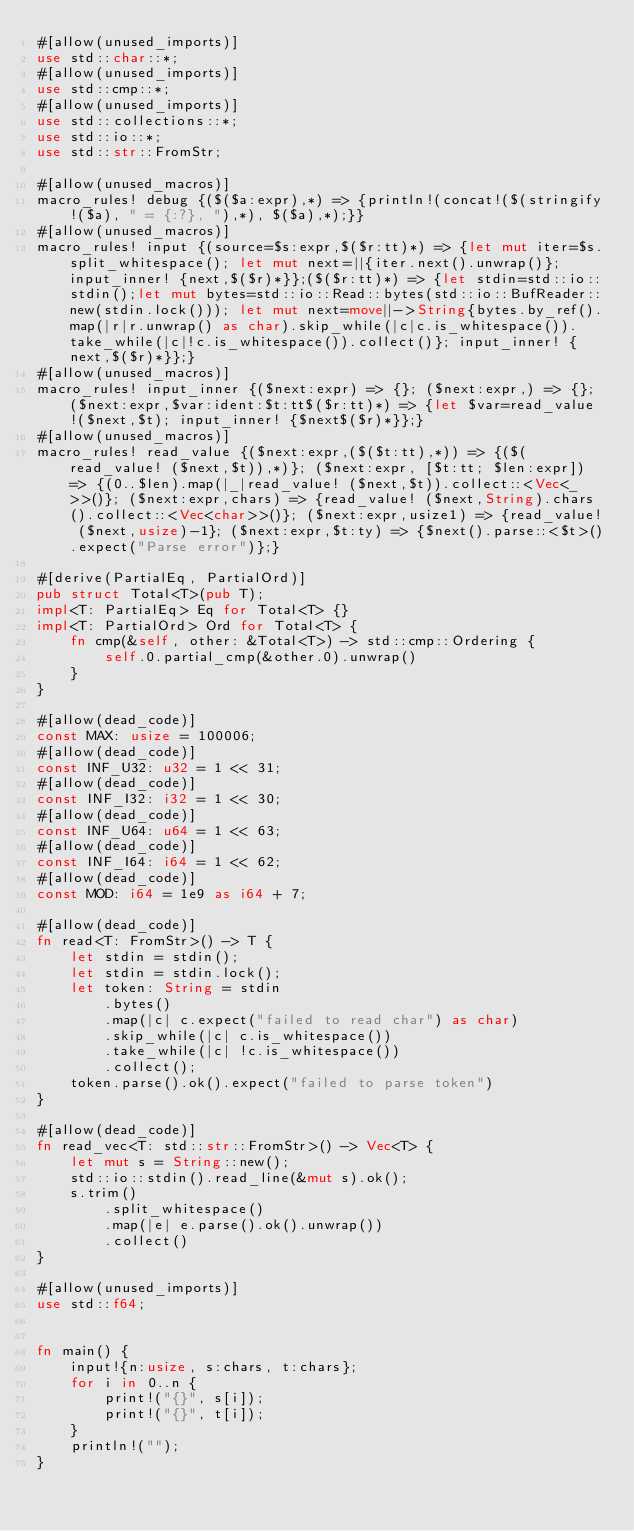Convert code to text. <code><loc_0><loc_0><loc_500><loc_500><_Rust_>#[allow(unused_imports)]
use std::char::*;
#[allow(unused_imports)]
use std::cmp::*;
#[allow(unused_imports)]
use std::collections::*;
use std::io::*;
use std::str::FromStr;

#[allow(unused_macros)]
macro_rules! debug {($($a:expr),*) => {println!(concat!($(stringify!($a), " = {:?}, "),*), $($a),*);}}
#[allow(unused_macros)]
macro_rules! input {(source=$s:expr,$($r:tt)*) => {let mut iter=$s.split_whitespace(); let mut next=||{iter.next().unwrap()}; input_inner! {next,$($r)*}};($($r:tt)*) => {let stdin=std::io::stdin();let mut bytes=std::io::Read::bytes(std::io::BufReader::new(stdin.lock())); let mut next=move||->String{bytes.by_ref().map(|r|r.unwrap() as char).skip_while(|c|c.is_whitespace()).take_while(|c|!c.is_whitespace()).collect()}; input_inner! {next,$($r)*}};}
#[allow(unused_macros)]
macro_rules! input_inner {($next:expr) => {}; ($next:expr,) => {}; ($next:expr,$var:ident:$t:tt$($r:tt)*) => {let $var=read_value!($next,$t); input_inner! {$next$($r)*}};}
#[allow(unused_macros)]
macro_rules! read_value {($next:expr,($($t:tt),*)) => {($(read_value! ($next,$t)),*)}; ($next:expr, [$t:tt; $len:expr]) => {(0..$len).map(|_|read_value! ($next,$t)).collect::<Vec<_>>()}; ($next:expr,chars) => {read_value! ($next,String).chars().collect::<Vec<char>>()}; ($next:expr,usize1) => {read_value! ($next,usize)-1}; ($next:expr,$t:ty) => {$next().parse::<$t>().expect("Parse error")};}

#[derive(PartialEq, PartialOrd)]
pub struct Total<T>(pub T);
impl<T: PartialEq> Eq for Total<T> {}
impl<T: PartialOrd> Ord for Total<T> {
    fn cmp(&self, other: &Total<T>) -> std::cmp::Ordering {
        self.0.partial_cmp(&other.0).unwrap()
    }
}

#[allow(dead_code)]
const MAX: usize = 100006;
#[allow(dead_code)]
const INF_U32: u32 = 1 << 31;
#[allow(dead_code)]
const INF_I32: i32 = 1 << 30;
#[allow(dead_code)]
const INF_U64: u64 = 1 << 63;
#[allow(dead_code)]
const INF_I64: i64 = 1 << 62;
#[allow(dead_code)]
const MOD: i64 = 1e9 as i64 + 7;

#[allow(dead_code)]
fn read<T: FromStr>() -> T {
    let stdin = stdin();
    let stdin = stdin.lock();
    let token: String = stdin
        .bytes()
        .map(|c| c.expect("failed to read char") as char)
        .skip_while(|c| c.is_whitespace())
        .take_while(|c| !c.is_whitespace())
        .collect();
    token.parse().ok().expect("failed to parse token")
}

#[allow(dead_code)]
fn read_vec<T: std::str::FromStr>() -> Vec<T> {
    let mut s = String::new();
    std::io::stdin().read_line(&mut s).ok();
    s.trim()
        .split_whitespace()
        .map(|e| e.parse().ok().unwrap())
        .collect()
}

#[allow(unused_imports)]
use std::f64;


fn main() {
    input!{n:usize, s:chars, t:chars};
    for i in 0..n {
        print!("{}", s[i]);
        print!("{}", t[i]);
    }
    println!("");
}
</code> 